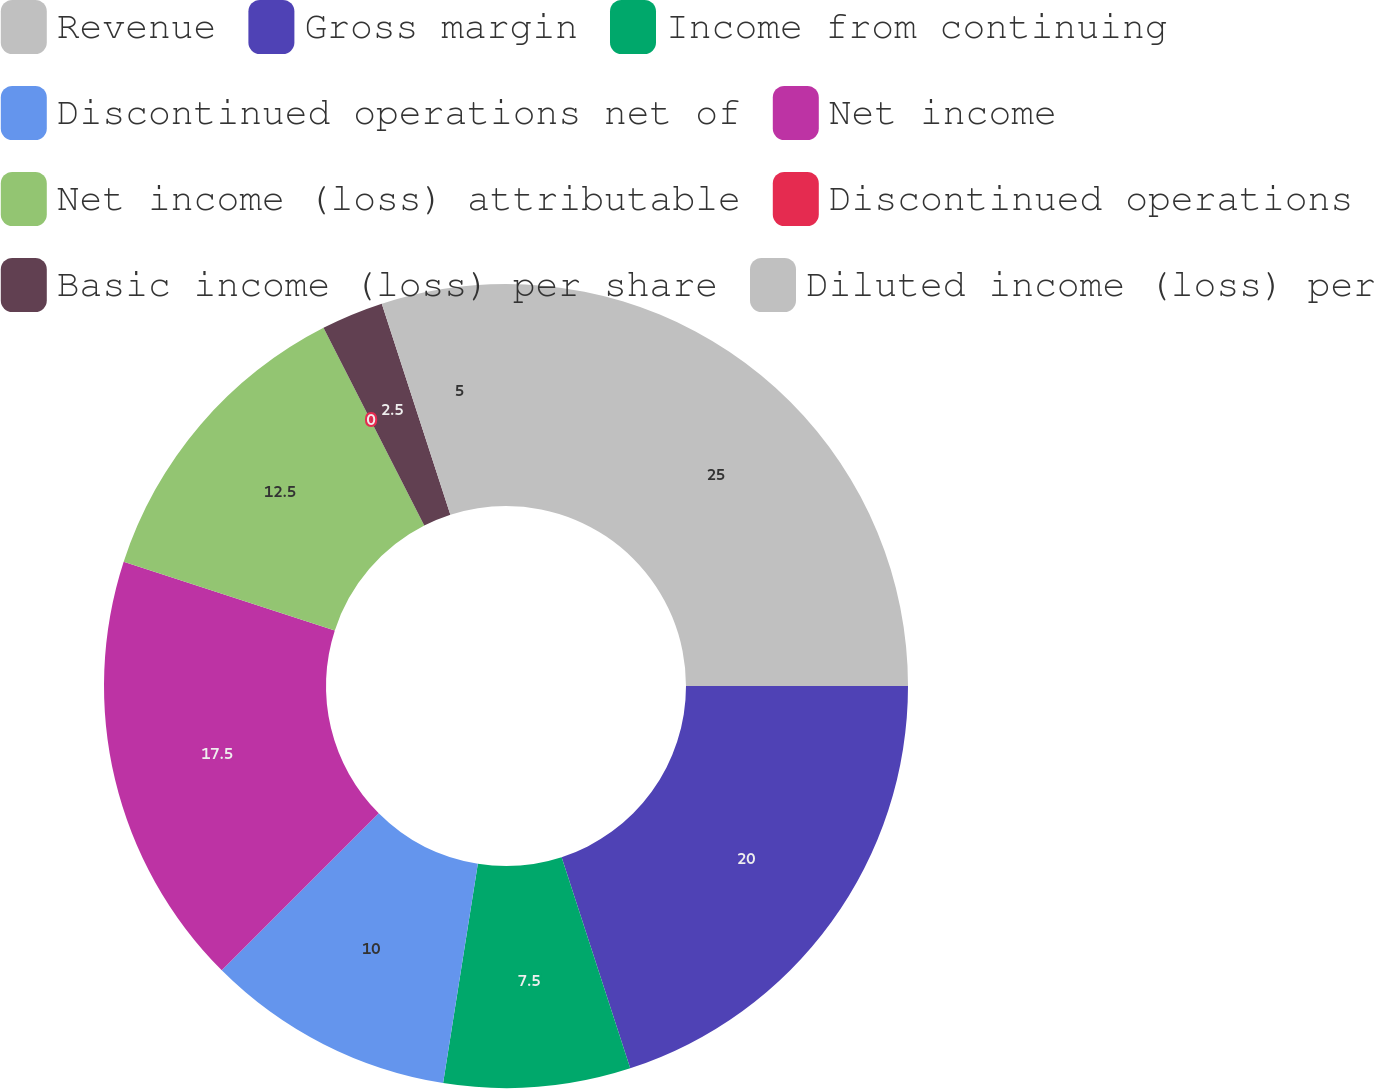<chart> <loc_0><loc_0><loc_500><loc_500><pie_chart><fcel>Revenue<fcel>Gross margin<fcel>Income from continuing<fcel>Discontinued operations net of<fcel>Net income<fcel>Net income (loss) attributable<fcel>Discontinued operations<fcel>Basic income (loss) per share<fcel>Diluted income (loss) per<nl><fcel>25.0%<fcel>20.0%<fcel>7.5%<fcel>10.0%<fcel>17.5%<fcel>12.5%<fcel>0.0%<fcel>2.5%<fcel>5.0%<nl></chart> 